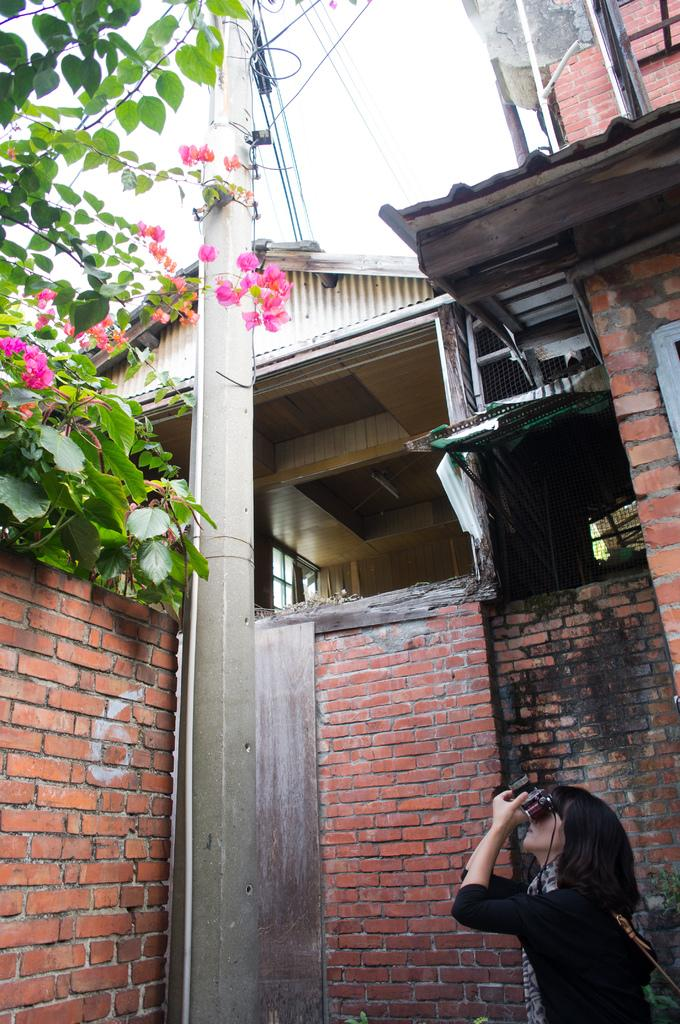Who is present in the image? There is a woman in the image. What can be seen in the background of the image? There is a building and the sky visible in the background of the image. What type of vegetation is present in the image? There are trees with flowers in the image. What is the purpose of the electric pole in the image? The electric pole is likely used for providing electricity to the area. What type of kick does the manager perform in the image? There is no manager or kick present in the image. 